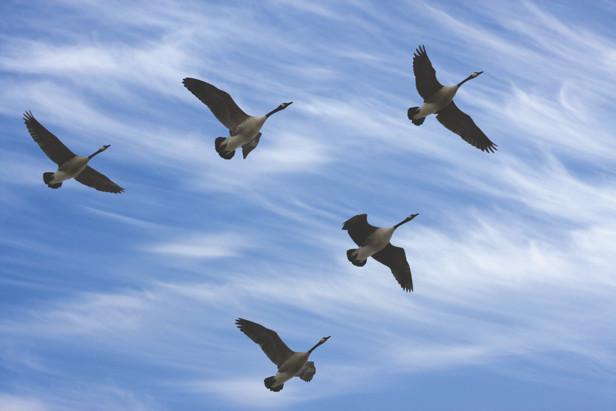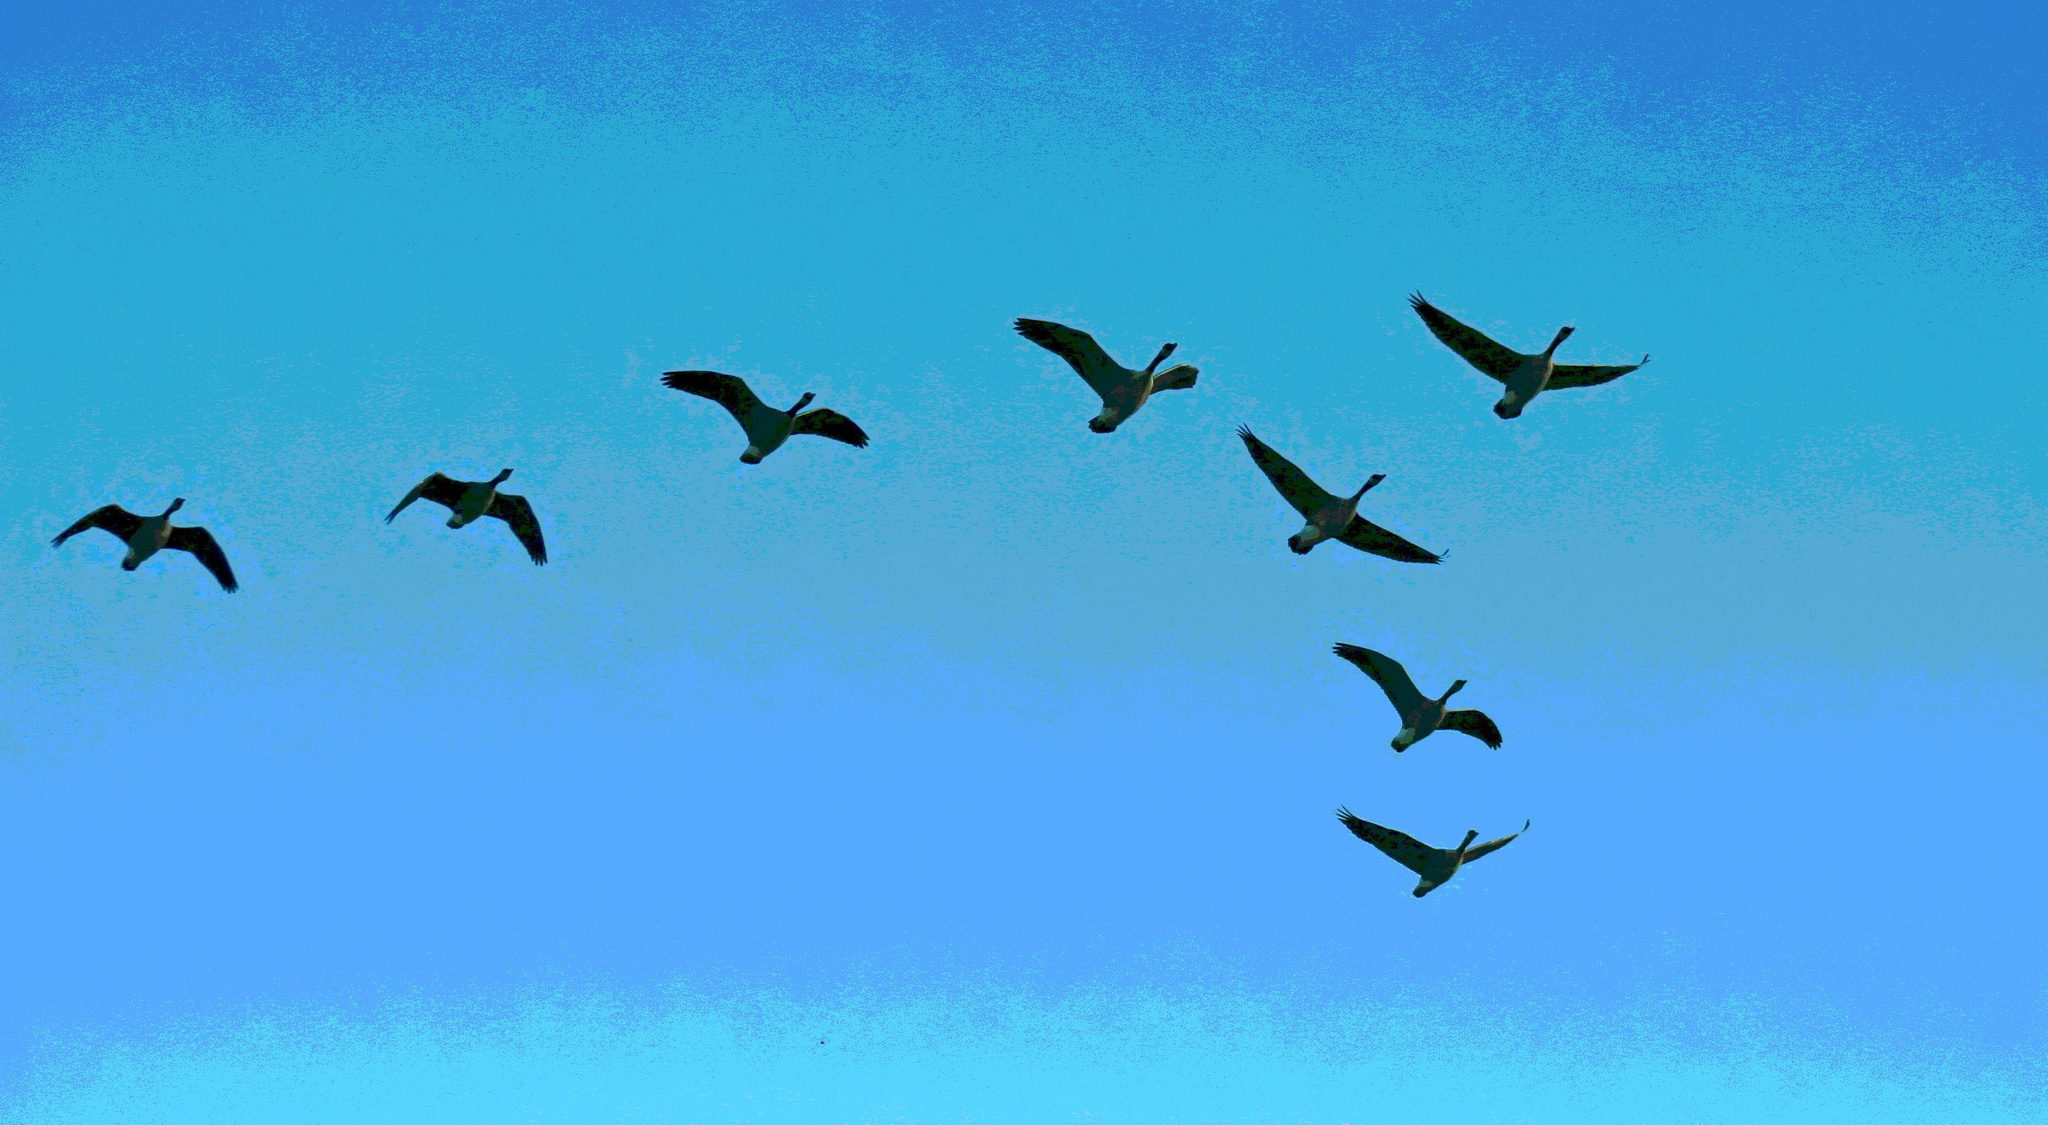The first image is the image on the left, the second image is the image on the right. Examine the images to the left and right. Is the description "there are 6 geese in flight" accurate? Answer yes or no. No. The first image is the image on the left, the second image is the image on the right. Evaluate the accuracy of this statement regarding the images: "The right image shows geese flying rightward in a V formation on a clear turquoise-blue sky.". Is it true? Answer yes or no. Yes. 